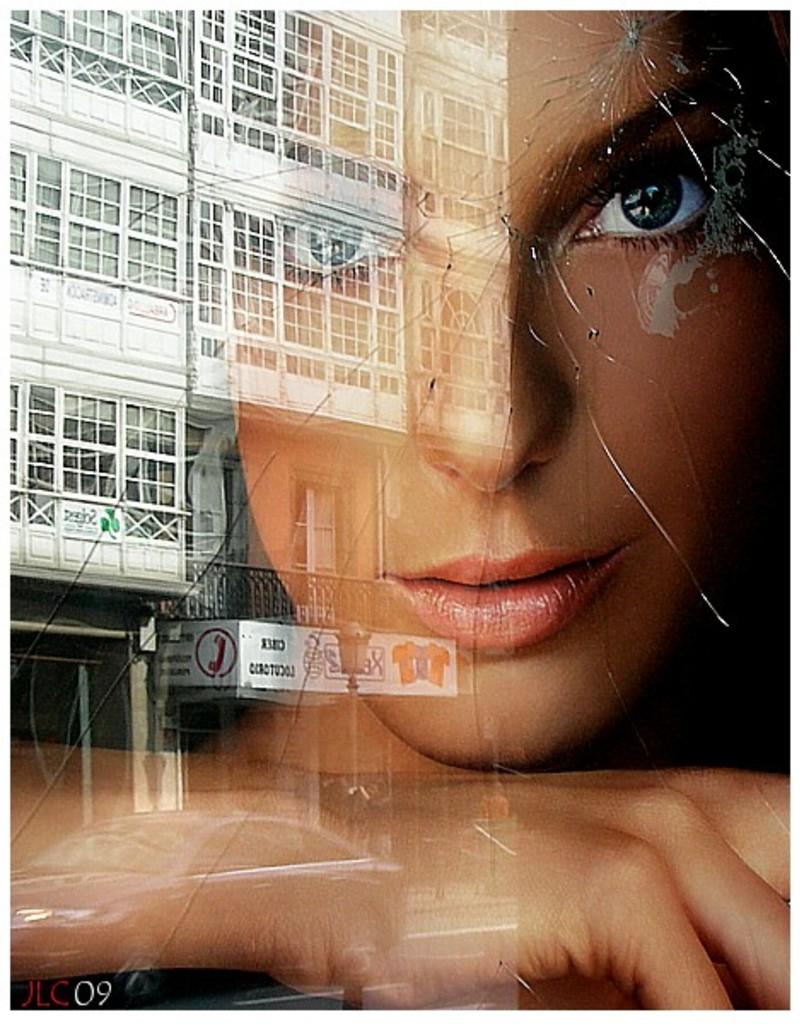What type of structure is present in the image? There is a building in the image. Can you describe any other elements in the image? The shadow of a girl's face is visible in the image. How many bears can be seen in the image? There are no bears present in the image. What year is depicted in the image? The image does not depict a specific year; it only shows a building and the shadow of a girl's face. 